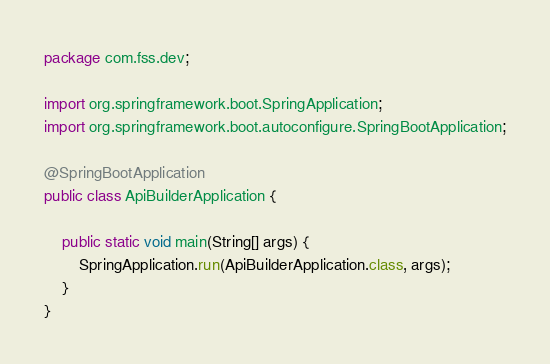<code> <loc_0><loc_0><loc_500><loc_500><_Java_>package com.fss.dev;

import org.springframework.boot.SpringApplication;
import org.springframework.boot.autoconfigure.SpringBootApplication;

@SpringBootApplication
public class ApiBuilderApplication {

	public static void main(String[] args) {
		SpringApplication.run(ApiBuilderApplication.class, args);
	}
}
</code> 